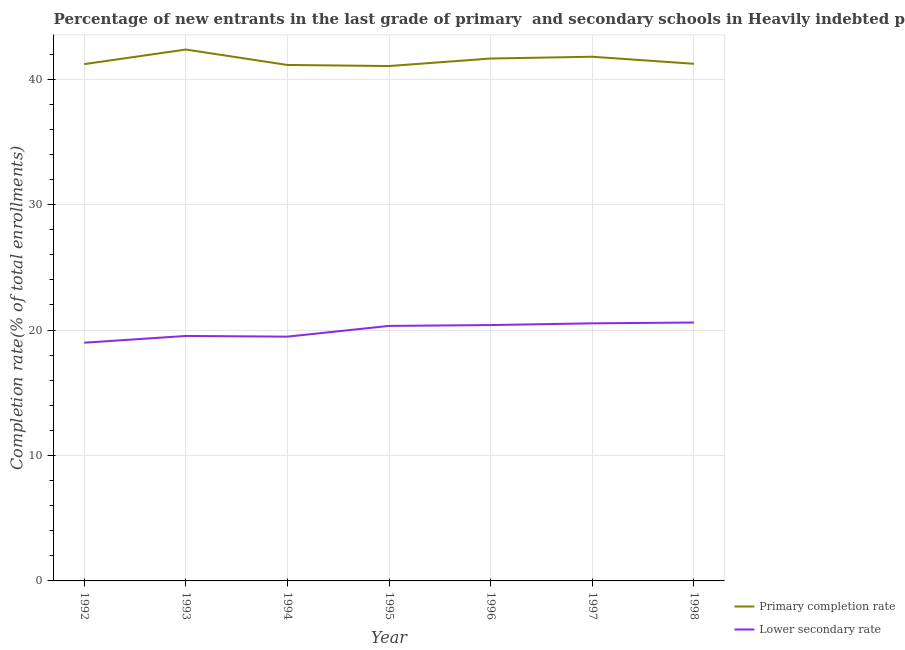How many different coloured lines are there?
Make the answer very short. 2. Is the number of lines equal to the number of legend labels?
Offer a terse response. Yes. What is the completion rate in primary schools in 1998?
Offer a terse response. 41.23. Across all years, what is the maximum completion rate in primary schools?
Your answer should be very brief. 42.36. Across all years, what is the minimum completion rate in secondary schools?
Provide a short and direct response. 18.99. What is the total completion rate in secondary schools in the graph?
Offer a very short reply. 139.86. What is the difference between the completion rate in primary schools in 1992 and that in 1997?
Provide a short and direct response. -0.59. What is the difference between the completion rate in primary schools in 1994 and the completion rate in secondary schools in 1992?
Keep it short and to the point. 22.14. What is the average completion rate in primary schools per year?
Give a very brief answer. 41.49. In the year 1995, what is the difference between the completion rate in secondary schools and completion rate in primary schools?
Offer a very short reply. -20.72. In how many years, is the completion rate in secondary schools greater than 36 %?
Your answer should be compact. 0. What is the ratio of the completion rate in primary schools in 1992 to that in 1997?
Give a very brief answer. 0.99. What is the difference between the highest and the second highest completion rate in secondary schools?
Provide a succinct answer. 0.07. What is the difference between the highest and the lowest completion rate in secondary schools?
Keep it short and to the point. 1.61. Is the completion rate in primary schools strictly greater than the completion rate in secondary schools over the years?
Give a very brief answer. Yes. Is the completion rate in primary schools strictly less than the completion rate in secondary schools over the years?
Keep it short and to the point. No. What is the difference between two consecutive major ticks on the Y-axis?
Make the answer very short. 10. Are the values on the major ticks of Y-axis written in scientific E-notation?
Your answer should be very brief. No. Does the graph contain grids?
Your response must be concise. Yes. Where does the legend appear in the graph?
Give a very brief answer. Bottom right. How are the legend labels stacked?
Make the answer very short. Vertical. What is the title of the graph?
Your answer should be compact. Percentage of new entrants in the last grade of primary  and secondary schools in Heavily indebted poor countries. What is the label or title of the Y-axis?
Your response must be concise. Completion rate(% of total enrollments). What is the Completion rate(% of total enrollments) in Primary completion rate in 1992?
Give a very brief answer. 41.2. What is the Completion rate(% of total enrollments) in Lower secondary rate in 1992?
Ensure brevity in your answer.  18.99. What is the Completion rate(% of total enrollments) of Primary completion rate in 1993?
Offer a terse response. 42.36. What is the Completion rate(% of total enrollments) in Lower secondary rate in 1993?
Your answer should be compact. 19.53. What is the Completion rate(% of total enrollments) in Primary completion rate in 1994?
Your answer should be compact. 41.14. What is the Completion rate(% of total enrollments) in Lower secondary rate in 1994?
Ensure brevity in your answer.  19.48. What is the Completion rate(% of total enrollments) of Primary completion rate in 1995?
Offer a terse response. 41.05. What is the Completion rate(% of total enrollments) of Lower secondary rate in 1995?
Make the answer very short. 20.33. What is the Completion rate(% of total enrollments) of Primary completion rate in 1996?
Keep it short and to the point. 41.65. What is the Completion rate(% of total enrollments) in Lower secondary rate in 1996?
Offer a very short reply. 20.4. What is the Completion rate(% of total enrollments) of Primary completion rate in 1997?
Give a very brief answer. 41.79. What is the Completion rate(% of total enrollments) of Lower secondary rate in 1997?
Offer a very short reply. 20.54. What is the Completion rate(% of total enrollments) in Primary completion rate in 1998?
Ensure brevity in your answer.  41.23. What is the Completion rate(% of total enrollments) of Lower secondary rate in 1998?
Provide a succinct answer. 20.6. Across all years, what is the maximum Completion rate(% of total enrollments) of Primary completion rate?
Give a very brief answer. 42.36. Across all years, what is the maximum Completion rate(% of total enrollments) of Lower secondary rate?
Offer a very short reply. 20.6. Across all years, what is the minimum Completion rate(% of total enrollments) of Primary completion rate?
Provide a succinct answer. 41.05. Across all years, what is the minimum Completion rate(% of total enrollments) of Lower secondary rate?
Your response must be concise. 18.99. What is the total Completion rate(% of total enrollments) in Primary completion rate in the graph?
Ensure brevity in your answer.  290.42. What is the total Completion rate(% of total enrollments) in Lower secondary rate in the graph?
Give a very brief answer. 139.86. What is the difference between the Completion rate(% of total enrollments) in Primary completion rate in 1992 and that in 1993?
Give a very brief answer. -1.16. What is the difference between the Completion rate(% of total enrollments) in Lower secondary rate in 1992 and that in 1993?
Your response must be concise. -0.54. What is the difference between the Completion rate(% of total enrollments) in Primary completion rate in 1992 and that in 1994?
Provide a succinct answer. 0.07. What is the difference between the Completion rate(% of total enrollments) of Lower secondary rate in 1992 and that in 1994?
Offer a very short reply. -0.48. What is the difference between the Completion rate(% of total enrollments) of Primary completion rate in 1992 and that in 1995?
Provide a succinct answer. 0.15. What is the difference between the Completion rate(% of total enrollments) in Lower secondary rate in 1992 and that in 1995?
Keep it short and to the point. -1.34. What is the difference between the Completion rate(% of total enrollments) in Primary completion rate in 1992 and that in 1996?
Give a very brief answer. -0.45. What is the difference between the Completion rate(% of total enrollments) in Lower secondary rate in 1992 and that in 1996?
Provide a short and direct response. -1.41. What is the difference between the Completion rate(% of total enrollments) of Primary completion rate in 1992 and that in 1997?
Your answer should be very brief. -0.59. What is the difference between the Completion rate(% of total enrollments) of Lower secondary rate in 1992 and that in 1997?
Give a very brief answer. -1.55. What is the difference between the Completion rate(% of total enrollments) in Primary completion rate in 1992 and that in 1998?
Provide a short and direct response. -0.03. What is the difference between the Completion rate(% of total enrollments) of Lower secondary rate in 1992 and that in 1998?
Offer a very short reply. -1.61. What is the difference between the Completion rate(% of total enrollments) of Primary completion rate in 1993 and that in 1994?
Offer a terse response. 1.23. What is the difference between the Completion rate(% of total enrollments) of Lower secondary rate in 1993 and that in 1994?
Your answer should be very brief. 0.05. What is the difference between the Completion rate(% of total enrollments) in Primary completion rate in 1993 and that in 1995?
Give a very brief answer. 1.32. What is the difference between the Completion rate(% of total enrollments) of Lower secondary rate in 1993 and that in 1995?
Your response must be concise. -0.8. What is the difference between the Completion rate(% of total enrollments) of Primary completion rate in 1993 and that in 1996?
Your answer should be compact. 0.72. What is the difference between the Completion rate(% of total enrollments) in Lower secondary rate in 1993 and that in 1996?
Offer a very short reply. -0.87. What is the difference between the Completion rate(% of total enrollments) of Primary completion rate in 1993 and that in 1997?
Provide a short and direct response. 0.57. What is the difference between the Completion rate(% of total enrollments) of Lower secondary rate in 1993 and that in 1997?
Your answer should be compact. -1.01. What is the difference between the Completion rate(% of total enrollments) of Primary completion rate in 1993 and that in 1998?
Give a very brief answer. 1.14. What is the difference between the Completion rate(% of total enrollments) of Lower secondary rate in 1993 and that in 1998?
Give a very brief answer. -1.07. What is the difference between the Completion rate(% of total enrollments) of Primary completion rate in 1994 and that in 1995?
Offer a very short reply. 0.09. What is the difference between the Completion rate(% of total enrollments) of Lower secondary rate in 1994 and that in 1995?
Your answer should be compact. -0.86. What is the difference between the Completion rate(% of total enrollments) of Primary completion rate in 1994 and that in 1996?
Offer a terse response. -0.51. What is the difference between the Completion rate(% of total enrollments) in Lower secondary rate in 1994 and that in 1996?
Make the answer very short. -0.92. What is the difference between the Completion rate(% of total enrollments) of Primary completion rate in 1994 and that in 1997?
Keep it short and to the point. -0.66. What is the difference between the Completion rate(% of total enrollments) in Lower secondary rate in 1994 and that in 1997?
Provide a short and direct response. -1.06. What is the difference between the Completion rate(% of total enrollments) in Primary completion rate in 1994 and that in 1998?
Ensure brevity in your answer.  -0.09. What is the difference between the Completion rate(% of total enrollments) in Lower secondary rate in 1994 and that in 1998?
Your answer should be very brief. -1.13. What is the difference between the Completion rate(% of total enrollments) in Primary completion rate in 1995 and that in 1996?
Make the answer very short. -0.6. What is the difference between the Completion rate(% of total enrollments) in Lower secondary rate in 1995 and that in 1996?
Keep it short and to the point. -0.07. What is the difference between the Completion rate(% of total enrollments) of Primary completion rate in 1995 and that in 1997?
Your response must be concise. -0.74. What is the difference between the Completion rate(% of total enrollments) of Lower secondary rate in 1995 and that in 1997?
Your response must be concise. -0.2. What is the difference between the Completion rate(% of total enrollments) of Primary completion rate in 1995 and that in 1998?
Offer a terse response. -0.18. What is the difference between the Completion rate(% of total enrollments) in Lower secondary rate in 1995 and that in 1998?
Keep it short and to the point. -0.27. What is the difference between the Completion rate(% of total enrollments) of Primary completion rate in 1996 and that in 1997?
Offer a terse response. -0.14. What is the difference between the Completion rate(% of total enrollments) in Lower secondary rate in 1996 and that in 1997?
Your answer should be compact. -0.14. What is the difference between the Completion rate(% of total enrollments) in Primary completion rate in 1996 and that in 1998?
Make the answer very short. 0.42. What is the difference between the Completion rate(% of total enrollments) of Lower secondary rate in 1996 and that in 1998?
Make the answer very short. -0.2. What is the difference between the Completion rate(% of total enrollments) of Primary completion rate in 1997 and that in 1998?
Offer a terse response. 0.56. What is the difference between the Completion rate(% of total enrollments) of Lower secondary rate in 1997 and that in 1998?
Provide a short and direct response. -0.07. What is the difference between the Completion rate(% of total enrollments) of Primary completion rate in 1992 and the Completion rate(% of total enrollments) of Lower secondary rate in 1993?
Provide a succinct answer. 21.67. What is the difference between the Completion rate(% of total enrollments) in Primary completion rate in 1992 and the Completion rate(% of total enrollments) in Lower secondary rate in 1994?
Provide a succinct answer. 21.73. What is the difference between the Completion rate(% of total enrollments) of Primary completion rate in 1992 and the Completion rate(% of total enrollments) of Lower secondary rate in 1995?
Your answer should be compact. 20.87. What is the difference between the Completion rate(% of total enrollments) of Primary completion rate in 1992 and the Completion rate(% of total enrollments) of Lower secondary rate in 1996?
Ensure brevity in your answer.  20.8. What is the difference between the Completion rate(% of total enrollments) in Primary completion rate in 1992 and the Completion rate(% of total enrollments) in Lower secondary rate in 1997?
Ensure brevity in your answer.  20.67. What is the difference between the Completion rate(% of total enrollments) of Primary completion rate in 1992 and the Completion rate(% of total enrollments) of Lower secondary rate in 1998?
Give a very brief answer. 20.6. What is the difference between the Completion rate(% of total enrollments) of Primary completion rate in 1993 and the Completion rate(% of total enrollments) of Lower secondary rate in 1994?
Offer a terse response. 22.89. What is the difference between the Completion rate(% of total enrollments) of Primary completion rate in 1993 and the Completion rate(% of total enrollments) of Lower secondary rate in 1995?
Keep it short and to the point. 22.03. What is the difference between the Completion rate(% of total enrollments) of Primary completion rate in 1993 and the Completion rate(% of total enrollments) of Lower secondary rate in 1996?
Ensure brevity in your answer.  21.97. What is the difference between the Completion rate(% of total enrollments) of Primary completion rate in 1993 and the Completion rate(% of total enrollments) of Lower secondary rate in 1997?
Your response must be concise. 21.83. What is the difference between the Completion rate(% of total enrollments) in Primary completion rate in 1993 and the Completion rate(% of total enrollments) in Lower secondary rate in 1998?
Offer a terse response. 21.76. What is the difference between the Completion rate(% of total enrollments) of Primary completion rate in 1994 and the Completion rate(% of total enrollments) of Lower secondary rate in 1995?
Give a very brief answer. 20.8. What is the difference between the Completion rate(% of total enrollments) of Primary completion rate in 1994 and the Completion rate(% of total enrollments) of Lower secondary rate in 1996?
Give a very brief answer. 20.74. What is the difference between the Completion rate(% of total enrollments) in Primary completion rate in 1994 and the Completion rate(% of total enrollments) in Lower secondary rate in 1997?
Provide a succinct answer. 20.6. What is the difference between the Completion rate(% of total enrollments) in Primary completion rate in 1994 and the Completion rate(% of total enrollments) in Lower secondary rate in 1998?
Keep it short and to the point. 20.53. What is the difference between the Completion rate(% of total enrollments) in Primary completion rate in 1995 and the Completion rate(% of total enrollments) in Lower secondary rate in 1996?
Offer a terse response. 20.65. What is the difference between the Completion rate(% of total enrollments) in Primary completion rate in 1995 and the Completion rate(% of total enrollments) in Lower secondary rate in 1997?
Keep it short and to the point. 20.51. What is the difference between the Completion rate(% of total enrollments) of Primary completion rate in 1995 and the Completion rate(% of total enrollments) of Lower secondary rate in 1998?
Offer a terse response. 20.45. What is the difference between the Completion rate(% of total enrollments) in Primary completion rate in 1996 and the Completion rate(% of total enrollments) in Lower secondary rate in 1997?
Provide a succinct answer. 21.11. What is the difference between the Completion rate(% of total enrollments) of Primary completion rate in 1996 and the Completion rate(% of total enrollments) of Lower secondary rate in 1998?
Make the answer very short. 21.05. What is the difference between the Completion rate(% of total enrollments) in Primary completion rate in 1997 and the Completion rate(% of total enrollments) in Lower secondary rate in 1998?
Your answer should be very brief. 21.19. What is the average Completion rate(% of total enrollments) of Primary completion rate per year?
Provide a succinct answer. 41.49. What is the average Completion rate(% of total enrollments) of Lower secondary rate per year?
Give a very brief answer. 19.98. In the year 1992, what is the difference between the Completion rate(% of total enrollments) in Primary completion rate and Completion rate(% of total enrollments) in Lower secondary rate?
Make the answer very short. 22.21. In the year 1993, what is the difference between the Completion rate(% of total enrollments) of Primary completion rate and Completion rate(% of total enrollments) of Lower secondary rate?
Your response must be concise. 22.83. In the year 1994, what is the difference between the Completion rate(% of total enrollments) in Primary completion rate and Completion rate(% of total enrollments) in Lower secondary rate?
Offer a terse response. 21.66. In the year 1995, what is the difference between the Completion rate(% of total enrollments) in Primary completion rate and Completion rate(% of total enrollments) in Lower secondary rate?
Provide a short and direct response. 20.72. In the year 1996, what is the difference between the Completion rate(% of total enrollments) of Primary completion rate and Completion rate(% of total enrollments) of Lower secondary rate?
Make the answer very short. 21.25. In the year 1997, what is the difference between the Completion rate(% of total enrollments) of Primary completion rate and Completion rate(% of total enrollments) of Lower secondary rate?
Offer a terse response. 21.25. In the year 1998, what is the difference between the Completion rate(% of total enrollments) of Primary completion rate and Completion rate(% of total enrollments) of Lower secondary rate?
Give a very brief answer. 20.63. What is the ratio of the Completion rate(% of total enrollments) of Primary completion rate in 1992 to that in 1993?
Make the answer very short. 0.97. What is the ratio of the Completion rate(% of total enrollments) in Lower secondary rate in 1992 to that in 1993?
Offer a terse response. 0.97. What is the ratio of the Completion rate(% of total enrollments) of Lower secondary rate in 1992 to that in 1994?
Offer a very short reply. 0.98. What is the ratio of the Completion rate(% of total enrollments) in Primary completion rate in 1992 to that in 1995?
Ensure brevity in your answer.  1. What is the ratio of the Completion rate(% of total enrollments) of Lower secondary rate in 1992 to that in 1995?
Offer a terse response. 0.93. What is the ratio of the Completion rate(% of total enrollments) of Primary completion rate in 1992 to that in 1996?
Make the answer very short. 0.99. What is the ratio of the Completion rate(% of total enrollments) of Lower secondary rate in 1992 to that in 1996?
Keep it short and to the point. 0.93. What is the ratio of the Completion rate(% of total enrollments) in Primary completion rate in 1992 to that in 1997?
Your response must be concise. 0.99. What is the ratio of the Completion rate(% of total enrollments) in Lower secondary rate in 1992 to that in 1997?
Offer a terse response. 0.92. What is the ratio of the Completion rate(% of total enrollments) of Lower secondary rate in 1992 to that in 1998?
Provide a short and direct response. 0.92. What is the ratio of the Completion rate(% of total enrollments) of Primary completion rate in 1993 to that in 1994?
Keep it short and to the point. 1.03. What is the ratio of the Completion rate(% of total enrollments) of Lower secondary rate in 1993 to that in 1994?
Give a very brief answer. 1. What is the ratio of the Completion rate(% of total enrollments) of Primary completion rate in 1993 to that in 1995?
Offer a terse response. 1.03. What is the ratio of the Completion rate(% of total enrollments) of Lower secondary rate in 1993 to that in 1995?
Provide a short and direct response. 0.96. What is the ratio of the Completion rate(% of total enrollments) of Primary completion rate in 1993 to that in 1996?
Offer a very short reply. 1.02. What is the ratio of the Completion rate(% of total enrollments) of Lower secondary rate in 1993 to that in 1996?
Keep it short and to the point. 0.96. What is the ratio of the Completion rate(% of total enrollments) of Primary completion rate in 1993 to that in 1997?
Your response must be concise. 1.01. What is the ratio of the Completion rate(% of total enrollments) of Lower secondary rate in 1993 to that in 1997?
Your answer should be very brief. 0.95. What is the ratio of the Completion rate(% of total enrollments) in Primary completion rate in 1993 to that in 1998?
Ensure brevity in your answer.  1.03. What is the ratio of the Completion rate(% of total enrollments) in Lower secondary rate in 1993 to that in 1998?
Keep it short and to the point. 0.95. What is the ratio of the Completion rate(% of total enrollments) of Lower secondary rate in 1994 to that in 1995?
Your answer should be compact. 0.96. What is the ratio of the Completion rate(% of total enrollments) of Lower secondary rate in 1994 to that in 1996?
Ensure brevity in your answer.  0.95. What is the ratio of the Completion rate(% of total enrollments) in Primary completion rate in 1994 to that in 1997?
Keep it short and to the point. 0.98. What is the ratio of the Completion rate(% of total enrollments) of Lower secondary rate in 1994 to that in 1997?
Ensure brevity in your answer.  0.95. What is the ratio of the Completion rate(% of total enrollments) of Primary completion rate in 1994 to that in 1998?
Your response must be concise. 1. What is the ratio of the Completion rate(% of total enrollments) in Lower secondary rate in 1994 to that in 1998?
Offer a very short reply. 0.95. What is the ratio of the Completion rate(% of total enrollments) of Primary completion rate in 1995 to that in 1996?
Keep it short and to the point. 0.99. What is the ratio of the Completion rate(% of total enrollments) in Primary completion rate in 1995 to that in 1997?
Provide a succinct answer. 0.98. What is the ratio of the Completion rate(% of total enrollments) of Lower secondary rate in 1995 to that in 1997?
Offer a very short reply. 0.99. What is the ratio of the Completion rate(% of total enrollments) in Lower secondary rate in 1995 to that in 1998?
Make the answer very short. 0.99. What is the ratio of the Completion rate(% of total enrollments) of Primary completion rate in 1996 to that in 1997?
Your answer should be compact. 1. What is the ratio of the Completion rate(% of total enrollments) of Primary completion rate in 1996 to that in 1998?
Provide a succinct answer. 1.01. What is the ratio of the Completion rate(% of total enrollments) of Primary completion rate in 1997 to that in 1998?
Your response must be concise. 1.01. What is the difference between the highest and the second highest Completion rate(% of total enrollments) in Primary completion rate?
Give a very brief answer. 0.57. What is the difference between the highest and the second highest Completion rate(% of total enrollments) of Lower secondary rate?
Give a very brief answer. 0.07. What is the difference between the highest and the lowest Completion rate(% of total enrollments) in Primary completion rate?
Keep it short and to the point. 1.32. What is the difference between the highest and the lowest Completion rate(% of total enrollments) in Lower secondary rate?
Provide a short and direct response. 1.61. 